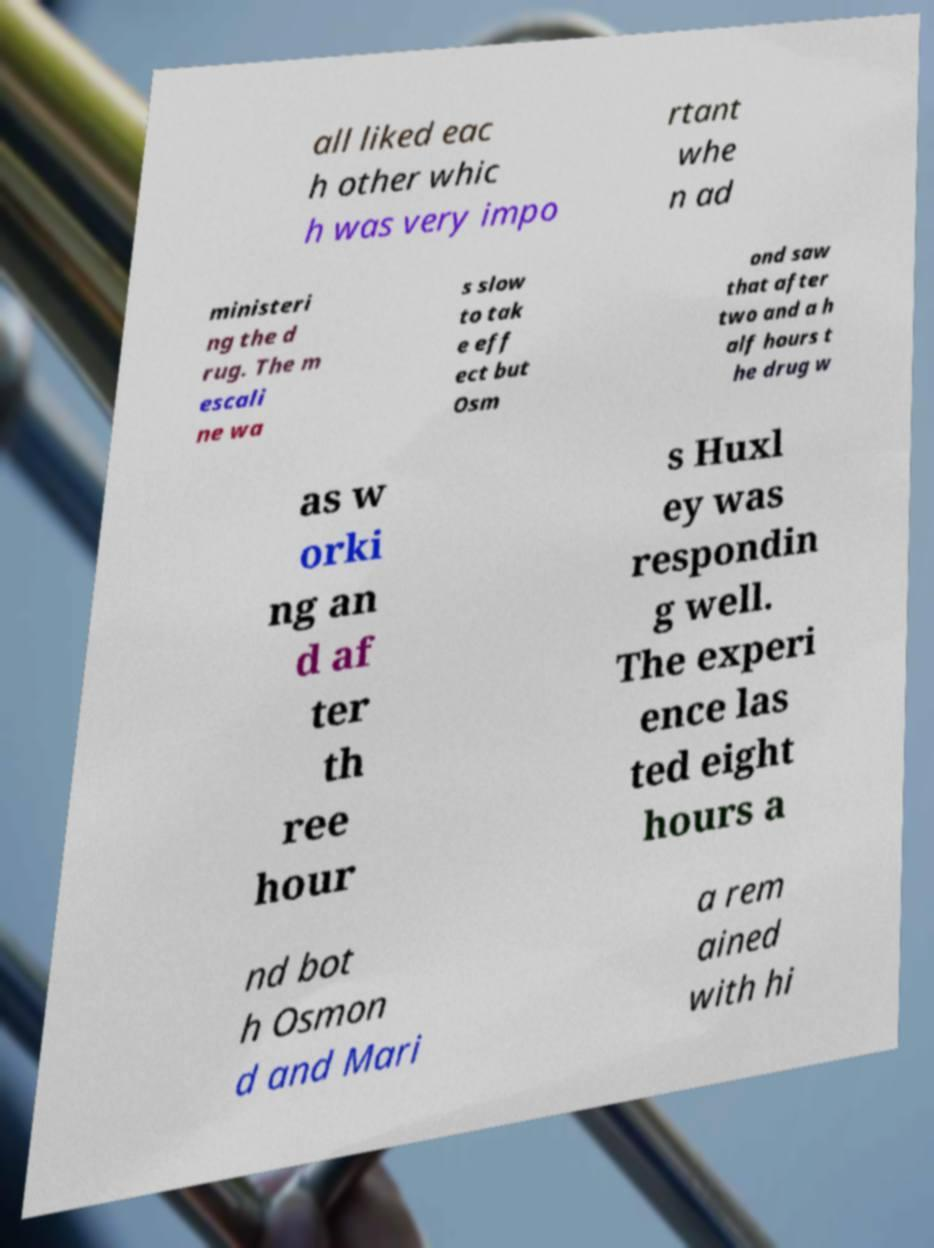What messages or text are displayed in this image? I need them in a readable, typed format. all liked eac h other whic h was very impo rtant whe n ad ministeri ng the d rug. The m escali ne wa s slow to tak e eff ect but Osm ond saw that after two and a h alf hours t he drug w as w orki ng an d af ter th ree hour s Huxl ey was respondin g well. The experi ence las ted eight hours a nd bot h Osmon d and Mari a rem ained with hi 